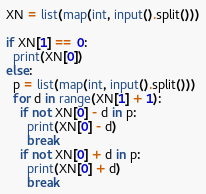<code> <loc_0><loc_0><loc_500><loc_500><_Python_>XN = list(map(int, input().split()))
 
if XN[1] == 0:
  print(XN[0])
else:
  p = list(map(int, input().split()))
  for d in range(XN[1] + 1):
    if not XN[0] - d in p:
      print(XN[0] - d)
      break
    if not XN[0] + d in p:
      print(XN[0] + d)
      break</code> 